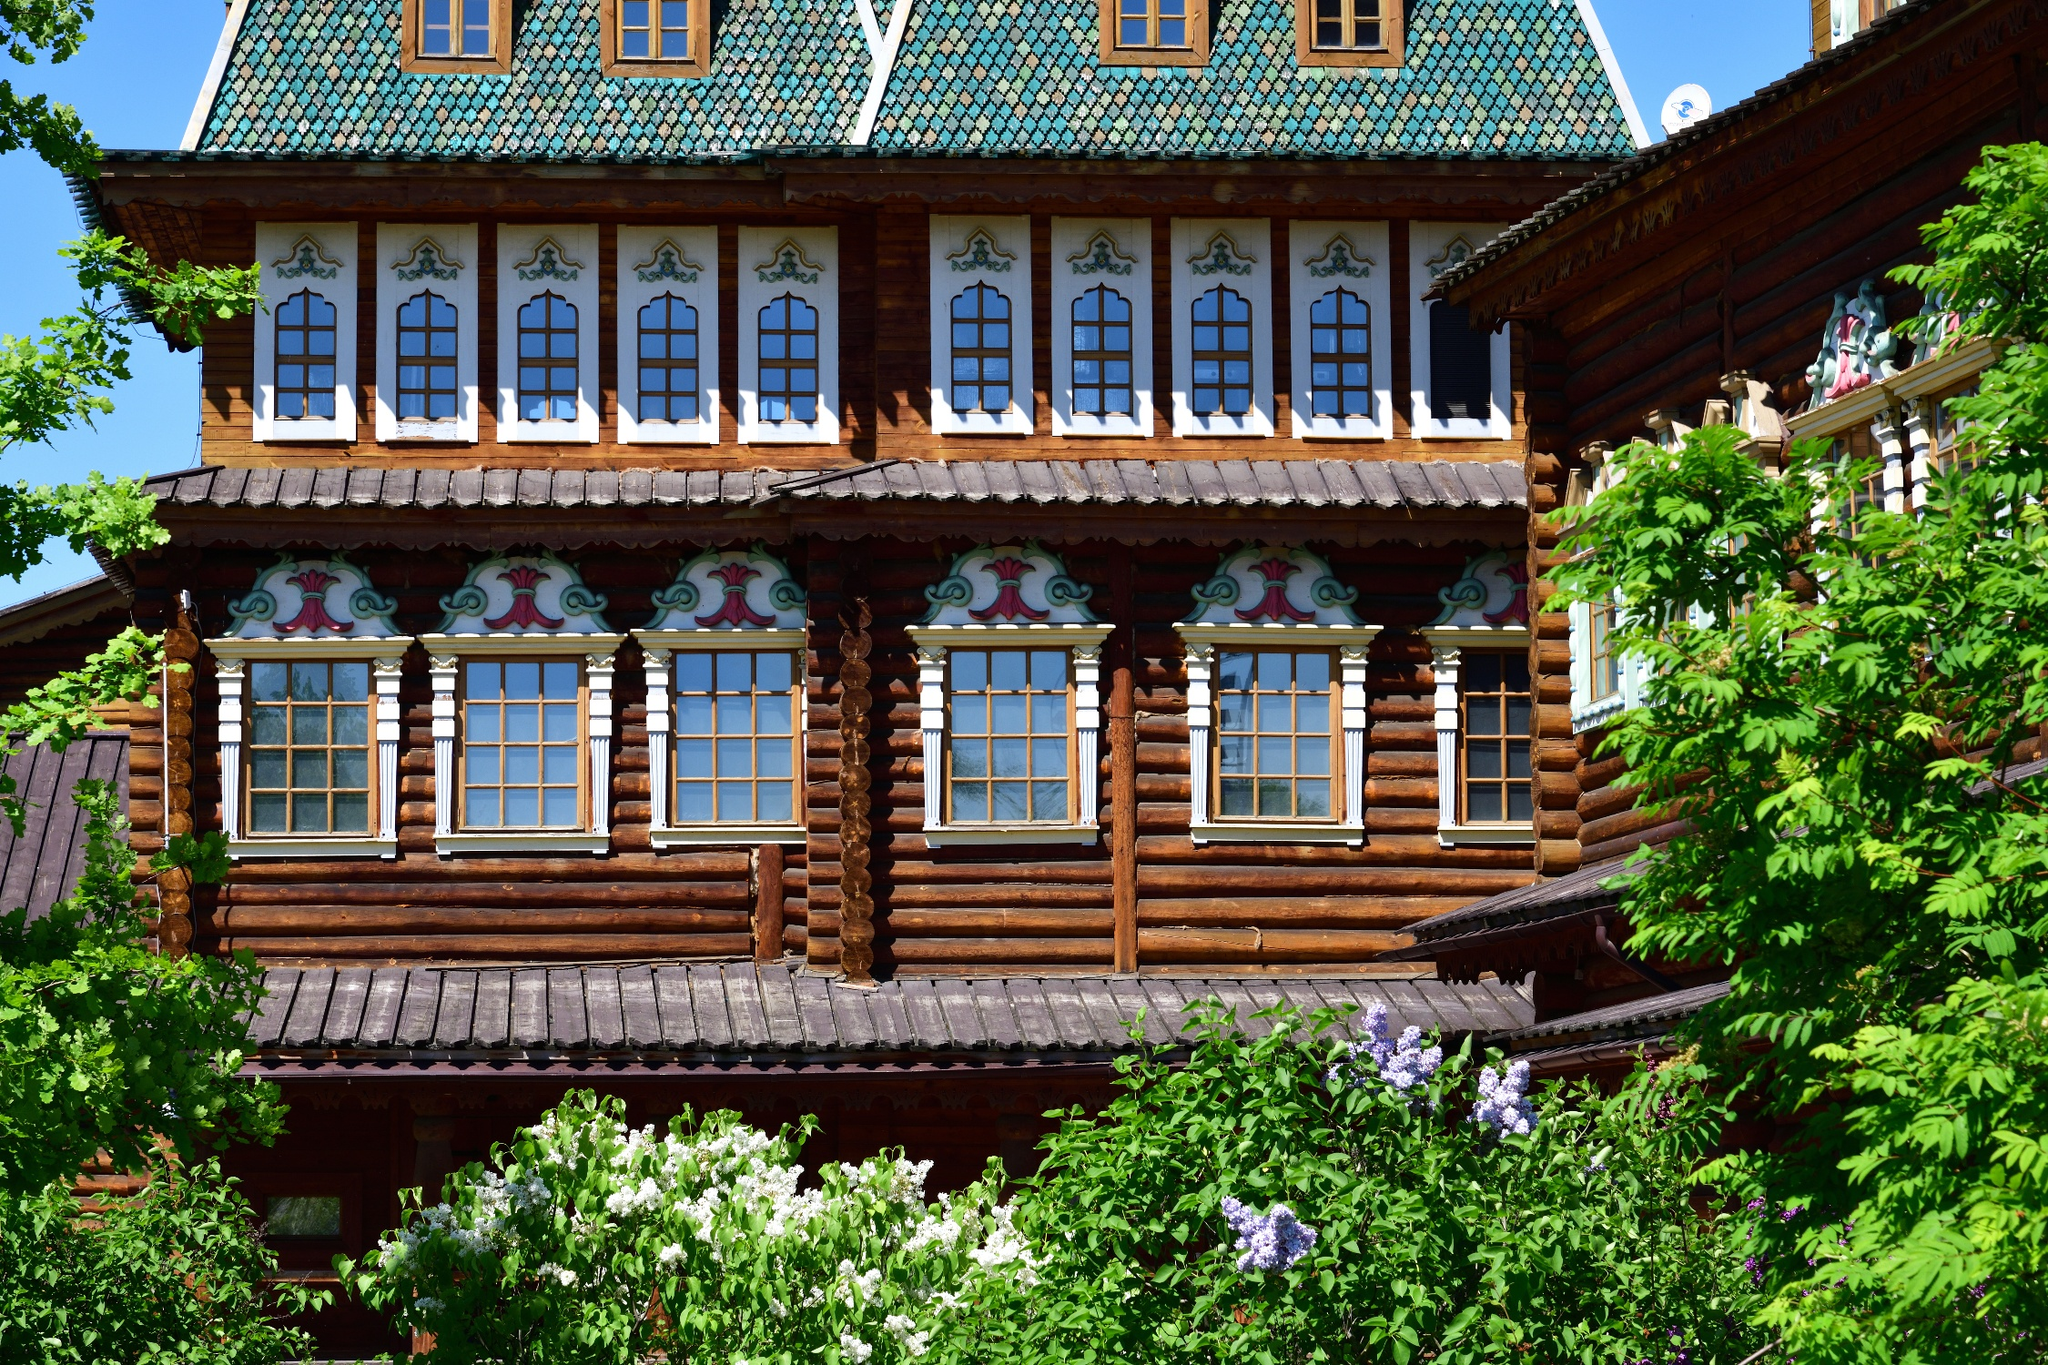What do you see happening in this image? The image captures the Wooden Palace of Tsar Alexei Mikhailovich, a notable landmark nestled in the village of Kolomenskoye, near Moscow, Russia. The palace, constructed entirely of wood, stands majestically against a backdrop of lush greenery. Its roof, painted a vibrant shade of green, contrasts beautifully with the natural wooden texture of the building. The windows, adorned with intricate, colorful patterns, add a touch of whimsy to the otherwise stately structure. The perspective of the photo, taken from a low angle, enhances the grandeur of the palace, making it appear as if it's reaching for the sky. The surrounding trees and bushes frame the palace, further emphasizing its architectural beauty. The image code 'sa_16817' could be a reference to the specific image or series it belongs to. 